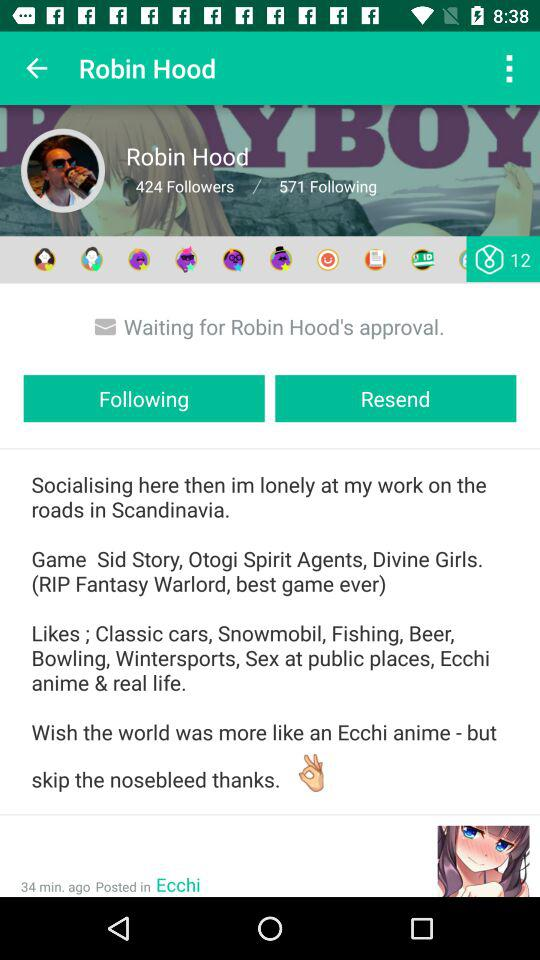How many people is Robin Hood following? Robin Hood is following 571 people. 